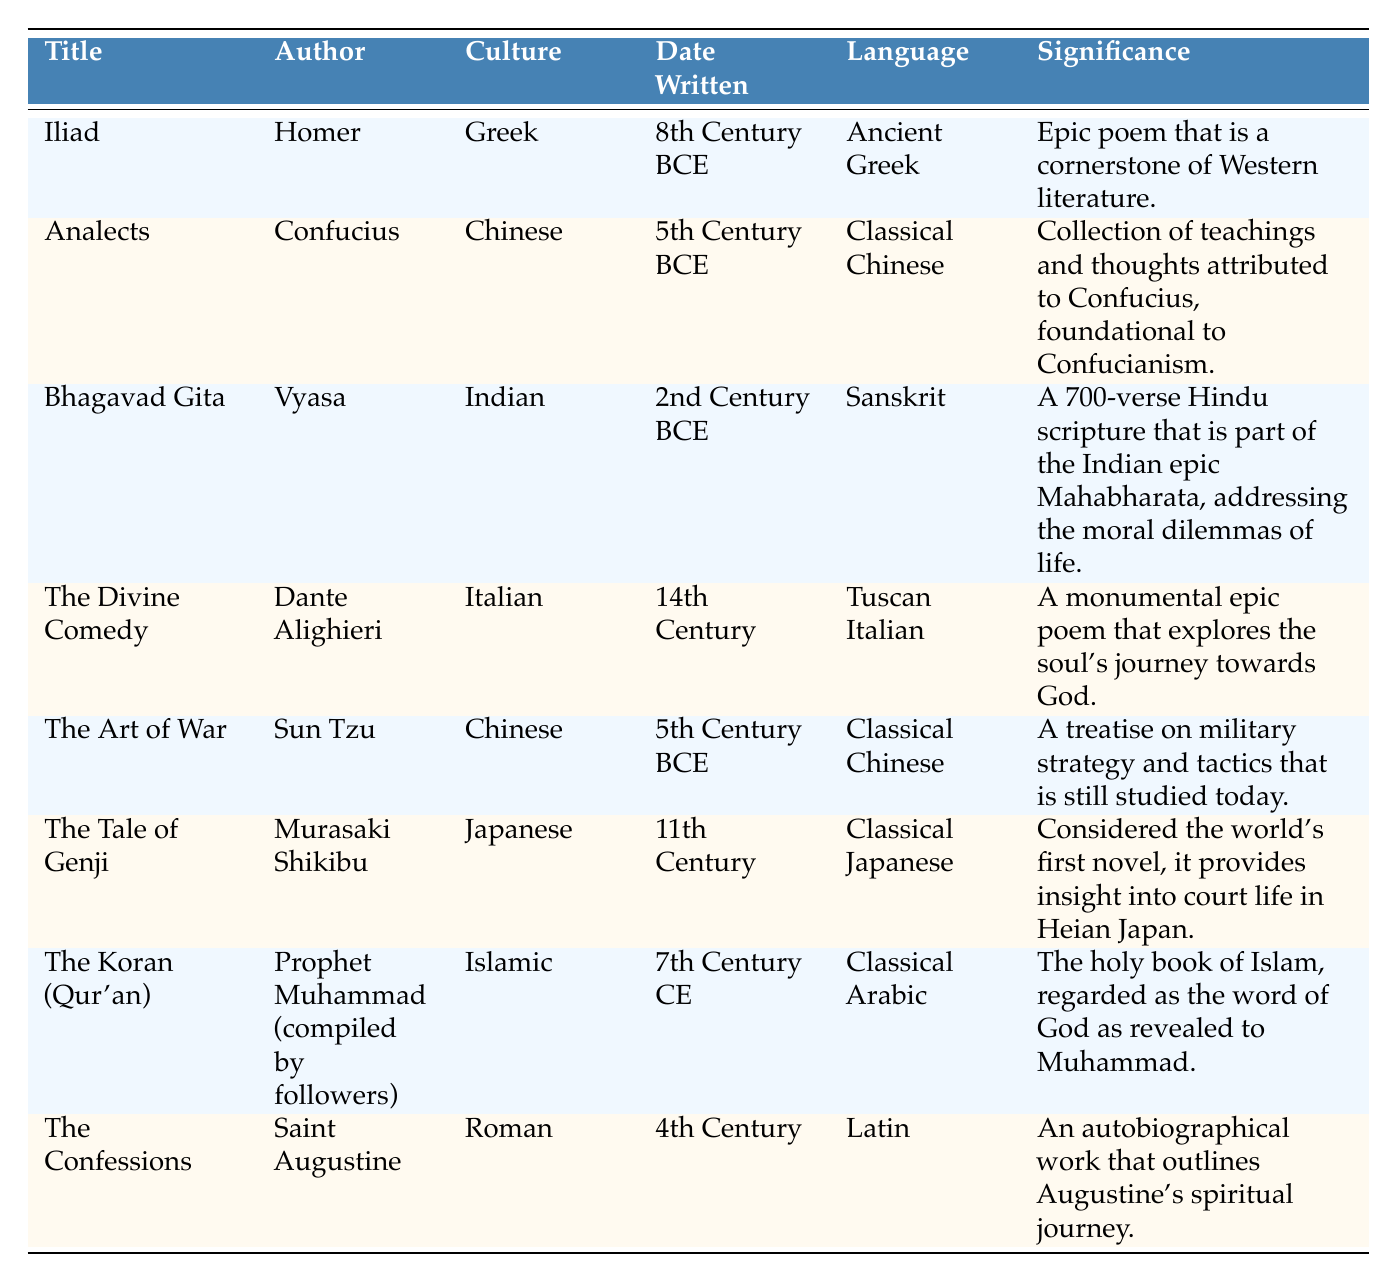What is the title of the historical text authored by Vyasa? The table shows that Vyasa is the author of the "Bhagavad Gita." Therefore, the title of the text is directly retrievable from the corresponding row.
Answer: Bhagavad Gita Which historical text was written in the 11th Century? According to the table, the "Tale of Genji" is listed as having been written in the 11th Century. This information can be found in the date written column for that specific title.
Answer: The Tale of Genji Is there a text that was written in Classical Chinese? Yes, both the "Analects" and "The Art of War" were written in Classical Chinese, as indicated in the language column of the respective rows for these texts.
Answer: Yes Which culture is represented by the "Divine Comedy"? The "Divine Comedy" is attributed to the Italian culture, as noted in the culture column in the table. This can be directly extracted from that specific row.
Answer: Italian What is the significance of the "Koran (Qur'an)"? The table states that the significance of the "Koran (Qur'an)" is that it is the holy book of Islam, regarded as the word of God as revealed to Muhammad. This information is provided in the significance column for that text.
Answer: The holy book of Islam Which two historical texts were written by authors from the same culture? Both the "Analects" and "The Art of War" were authored by individuals from Chinese culture. By inspecting the culture column, we can see that both texts share the culture designation of "Chinese."
Answer: Analects and The Art of War How many historical texts in the table were written before the 1st Century CE? The texts "Iliad," "Analects," "Bhagavad Gita," and "The Art of War" were all written before the 1st Century CE, which can be verified by examining the date written column for each title. Hence, there are four texts in total.
Answer: 4 Which language was used for the "Iliad"? The "Iliad" was written in Ancient Greek, as listed in the language column associated with this text in the table. This information is straightforward and can be easily retrieved.
Answer: Ancient Greek Which text explores moral dilemmas and who is the author? The "Bhagavad Gita" explores the moral dilemmas of life according to its significance description, and it is authored by Vyasa. Both pieces of information can be referenced from the corresponding rows.
Answer: Bhagavad Gita, Vyasa What is the average date of writing for the texts listed in the table? Calculating the average date of writing involves converting the dates into comparable forms. The respective centuries or approximate centuries (BCE/CE) are estimated as follows: Iliad (circa -800), Analects (circa -500), Bhagavad Gita (circa -200), The Art of War (circa -500), The Confessions (circa 400), The Koran (circa 600), The Tale of Genji (circa 1100), and The Divine Comedy (circa 1400). Adding these gives a rough total of -500 (average of -800, -500, -200, -500, 400, 600, 1100, 1400). There are thus 8 texts with a total average of approximately -506.25 (which we can more practically refer to as late 5th Century BCE). Therefore, the answer is late 5th Century BCE.
Answer: Late 5th Century BCE 